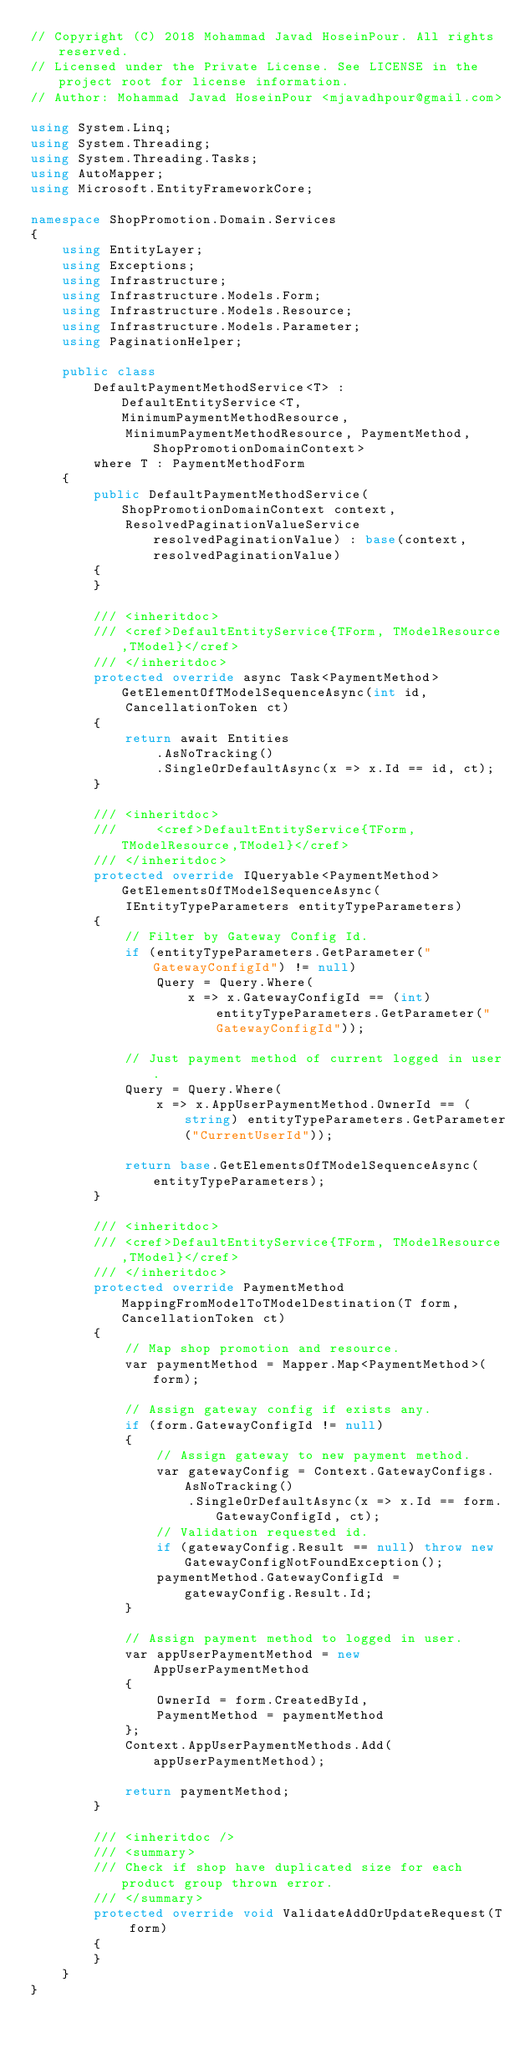Convert code to text. <code><loc_0><loc_0><loc_500><loc_500><_C#_>// Copyright (C) 2018 Mohammad Javad HoseinPour. All rights reserved.
// Licensed under the Private License. See LICENSE in the project root for license information.
// Author: Mohammad Javad HoseinPour <mjavadhpour@gmail.com>

using System.Linq;
using System.Threading;
using System.Threading.Tasks;
using AutoMapper;
using Microsoft.EntityFrameworkCore;

namespace ShopPromotion.Domain.Services
{
    using EntityLayer;
    using Exceptions;
    using Infrastructure;
    using Infrastructure.Models.Form;
    using Infrastructure.Models.Resource;
    using Infrastructure.Models.Parameter;
    using PaginationHelper;

    public class
        DefaultPaymentMethodService<T> : DefaultEntityService<T, MinimumPaymentMethodResource,
            MinimumPaymentMethodResource, PaymentMethod, ShopPromotionDomainContext>
        where T : PaymentMethodForm
    {
        public DefaultPaymentMethodService(ShopPromotionDomainContext context,
            ResolvedPaginationValueService resolvedPaginationValue) : base(context, resolvedPaginationValue)
        {
        }

        /// <inheritdoc>
        /// <cref>DefaultEntityService{TForm, TModelResource,TModel}</cref>
        /// </inheritdoc>
        protected override async Task<PaymentMethod> GetElementOfTModelSequenceAsync(int id,
            CancellationToken ct)
        {
            return await Entities
                .AsNoTracking()
                .SingleOrDefaultAsync(x => x.Id == id, ct);
        }

        /// <inheritdoc>
        ///     <cref>DefaultEntityService{TForm, TModelResource,TModel}</cref>
        /// </inheritdoc>
        protected override IQueryable<PaymentMethod> GetElementsOfTModelSequenceAsync(
            IEntityTypeParameters entityTypeParameters)
        {
            // Filter by Gateway Config Id.
            if (entityTypeParameters.GetParameter("GatewayConfigId") != null)
                Query = Query.Where(
                    x => x.GatewayConfigId == (int) entityTypeParameters.GetParameter("GatewayConfigId"));

            // Just payment method of current logged in user.
            Query = Query.Where(
                x => x.AppUserPaymentMethod.OwnerId == (string) entityTypeParameters.GetParameter("CurrentUserId"));

            return base.GetElementsOfTModelSequenceAsync(entityTypeParameters);
        }

        /// <inheritdoc>
        /// <cref>DefaultEntityService{TForm, TModelResource,TModel}</cref>
        /// </inheritdoc>
        protected override PaymentMethod MappingFromModelToTModelDestination(T form, CancellationToken ct)
        {
            // Map shop promotion and resource.
            var paymentMethod = Mapper.Map<PaymentMethod>(form);

            // Assign gateway config if exists any.
            if (form.GatewayConfigId != null)
            {
                // Assign gateway to new payment method.
                var gatewayConfig = Context.GatewayConfigs.AsNoTracking()
                    .SingleOrDefaultAsync(x => x.Id == form.GatewayConfigId, ct);
                // Validation requested id.
                if (gatewayConfig.Result == null) throw new GatewayConfigNotFoundException();
                paymentMethod.GatewayConfigId = gatewayConfig.Result.Id;
            }

            // Assign payment method to logged in user.
            var appUserPaymentMethod = new AppUserPaymentMethod
            {
                OwnerId = form.CreatedById,
                PaymentMethod = paymentMethod 
            };
            Context.AppUserPaymentMethods.Add(appUserPaymentMethod);

            return paymentMethod;
        }

        /// <inheritdoc />
        /// <summary>
        /// Check if shop have duplicated size for each product group thrown error.
        /// </summary>
        protected override void ValidateAddOrUpdateRequest(T form)
        {
        }
    }
}</code> 